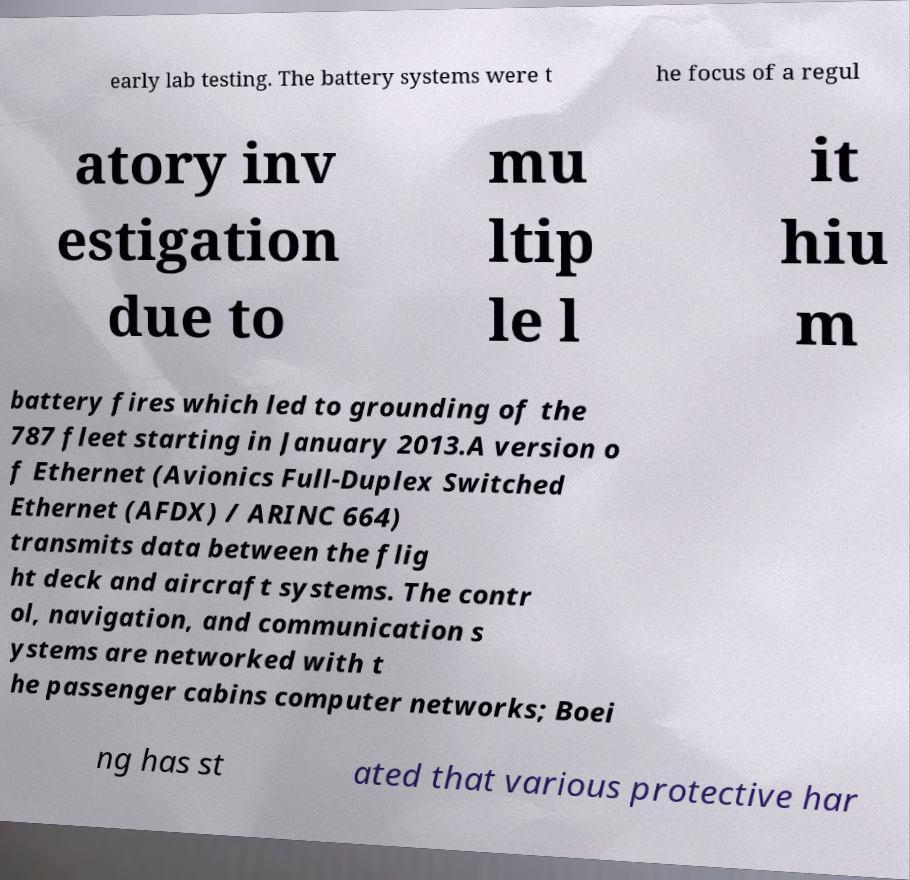Could you assist in decoding the text presented in this image and type it out clearly? early lab testing. The battery systems were t he focus of a regul atory inv estigation due to mu ltip le l it hiu m battery fires which led to grounding of the 787 fleet starting in January 2013.A version o f Ethernet (Avionics Full-Duplex Switched Ethernet (AFDX) / ARINC 664) transmits data between the flig ht deck and aircraft systems. The contr ol, navigation, and communication s ystems are networked with t he passenger cabins computer networks; Boei ng has st ated that various protective har 